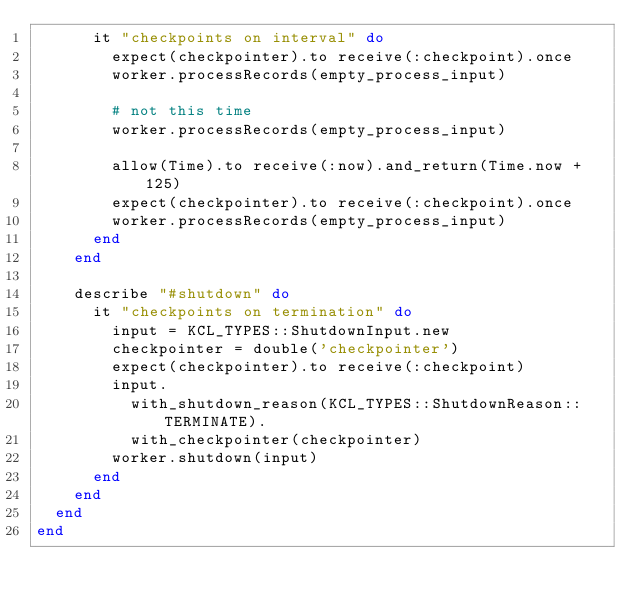Convert code to text. <code><loc_0><loc_0><loc_500><loc_500><_Ruby_>      it "checkpoints on interval" do
        expect(checkpointer).to receive(:checkpoint).once
        worker.processRecords(empty_process_input)

        # not this time
        worker.processRecords(empty_process_input)

        allow(Time).to receive(:now).and_return(Time.now + 125)
        expect(checkpointer).to receive(:checkpoint).once
        worker.processRecords(empty_process_input)
      end
    end

    describe "#shutdown" do
      it "checkpoints on termination" do
        input = KCL_TYPES::ShutdownInput.new
        checkpointer = double('checkpointer')
        expect(checkpointer).to receive(:checkpoint)
        input.
          with_shutdown_reason(KCL_TYPES::ShutdownReason::TERMINATE).
          with_checkpointer(checkpointer)
        worker.shutdown(input)
      end
    end
  end
end
</code> 